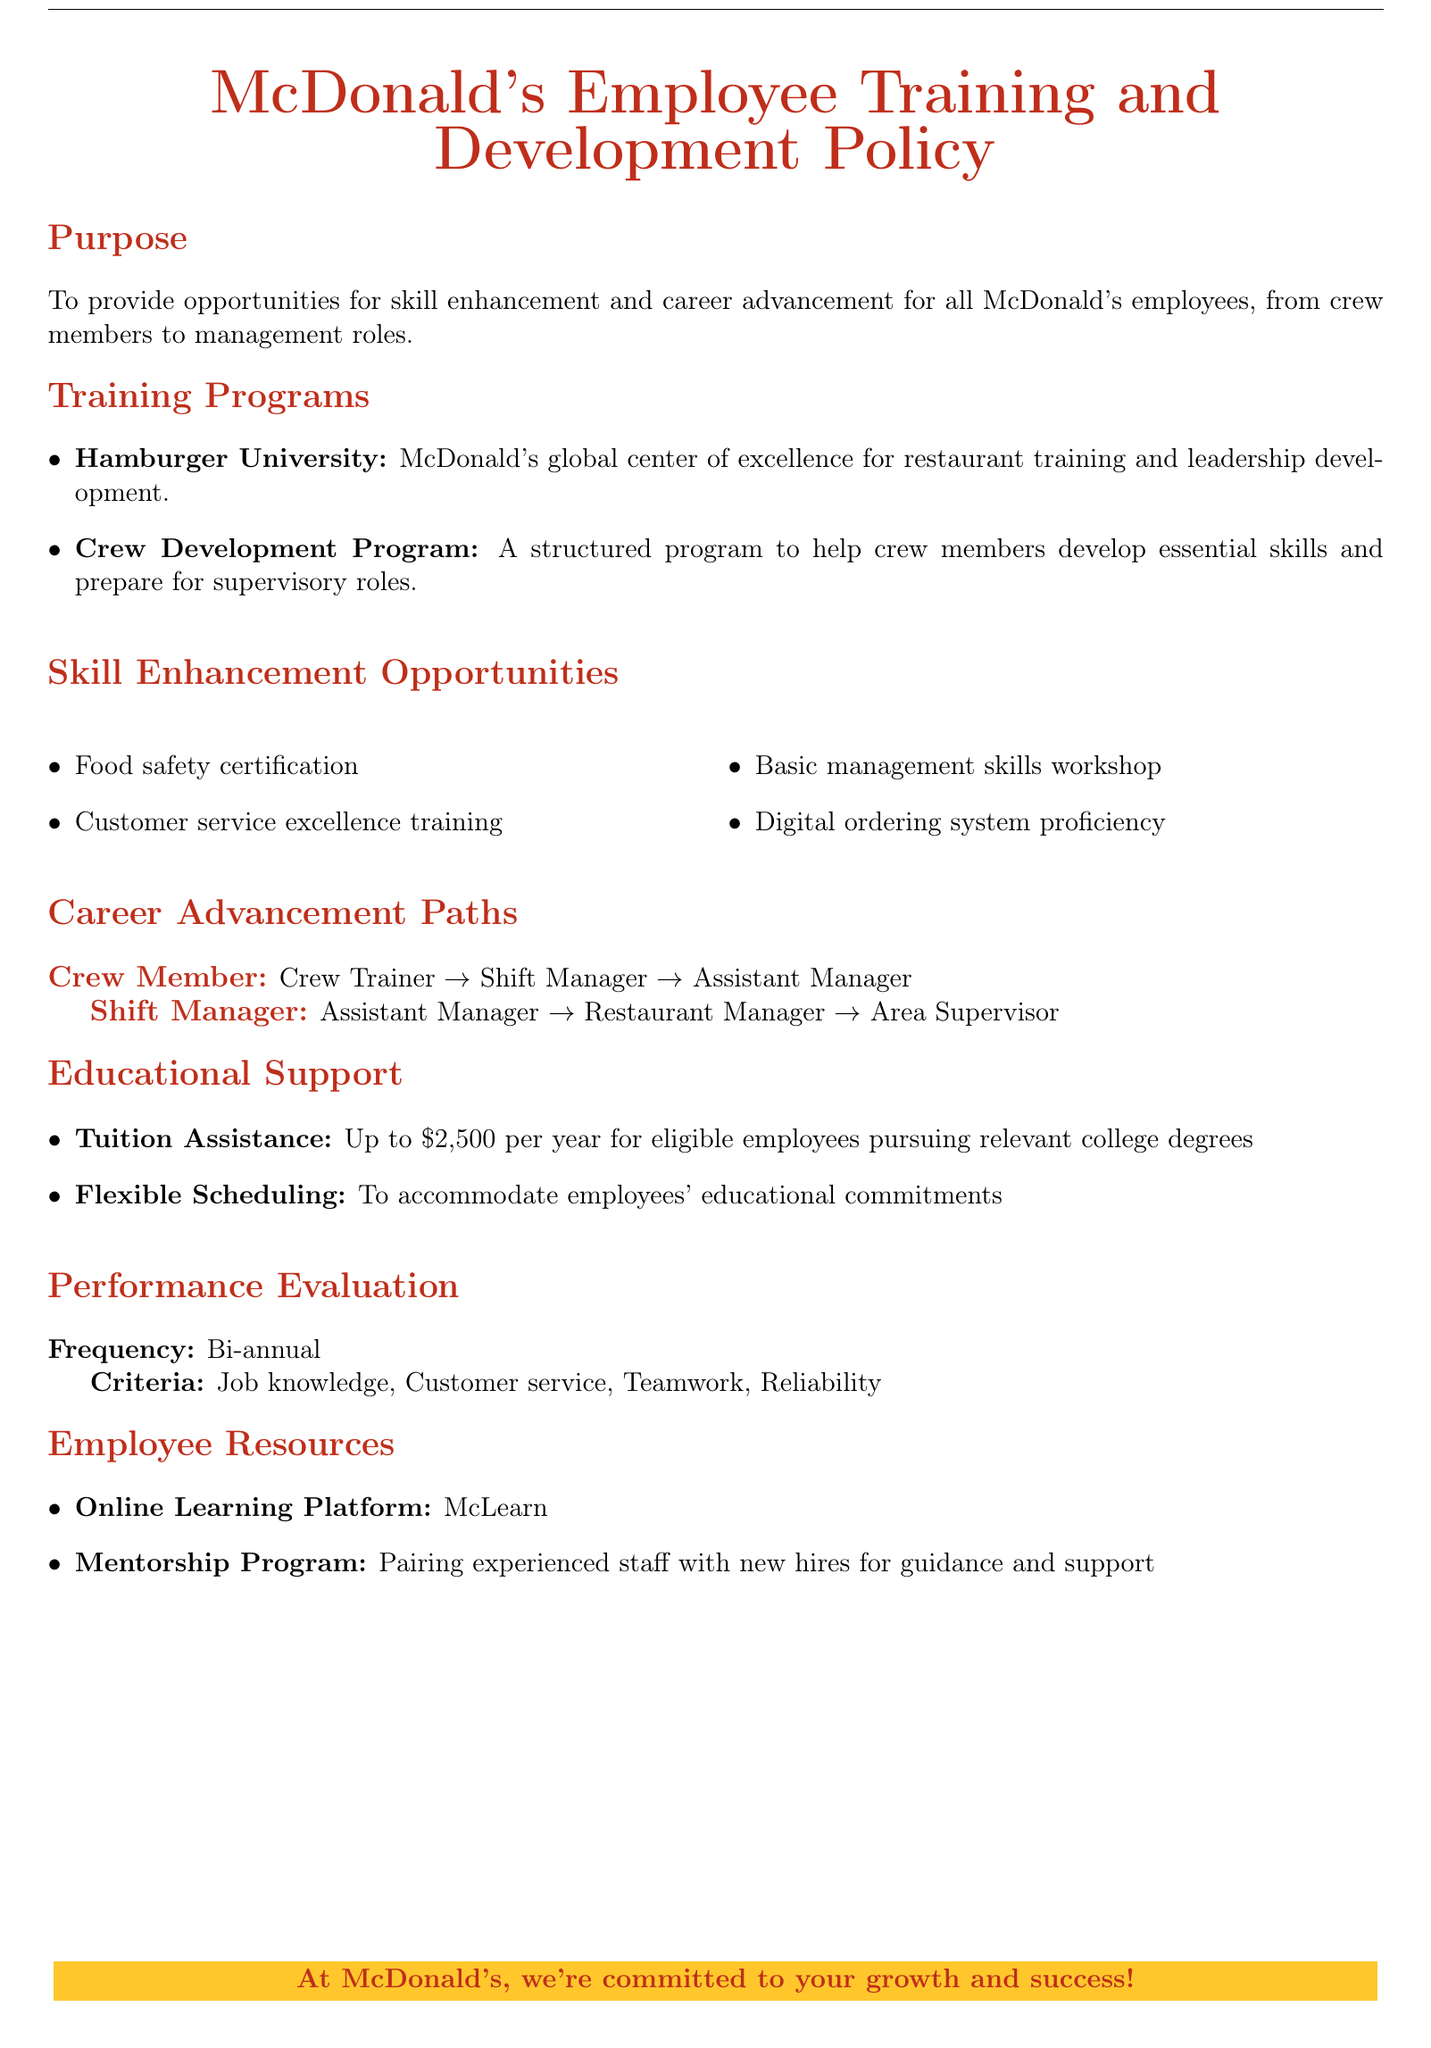What is the purpose of the Training and Development Policy? The purpose is to provide opportunities for skill enhancement and career advancement for all McDonald's employees.
Answer: Opportunities for skill enhancement and career advancement for all McDonald's employees What is the maximum tuition assistance available per year? The document states that eligible employees can receive up to $2,500 per year for college degrees.
Answer: $2,500 Name a skill enhancement opportunity mentioned in the document. The document lists several skill enhancement opportunities, one of which is food safety certification.
Answer: Food safety certification What is the first position in the Crew Member career advancement path? The document outlines that the first position is Crew Trainer in the Crew Member path.
Answer: Crew Trainer How frequently are performance evaluations conducted? The document specifies that performance evaluations are conducted bi-annually.
Answer: Bi-annual What platform is mentioned for online learning? The document names McLearn as the online learning platform available for employees.
Answer: McLearn Who is paired with new hires in the mentorship program? The document indicates that experienced staff are paired with new hires for guidance.
Answer: Experienced staff What program helps crew members prepare for supervisory roles? The document mentions the Crew Development Program as a structured program for this purpose.
Answer: Crew Development Program 